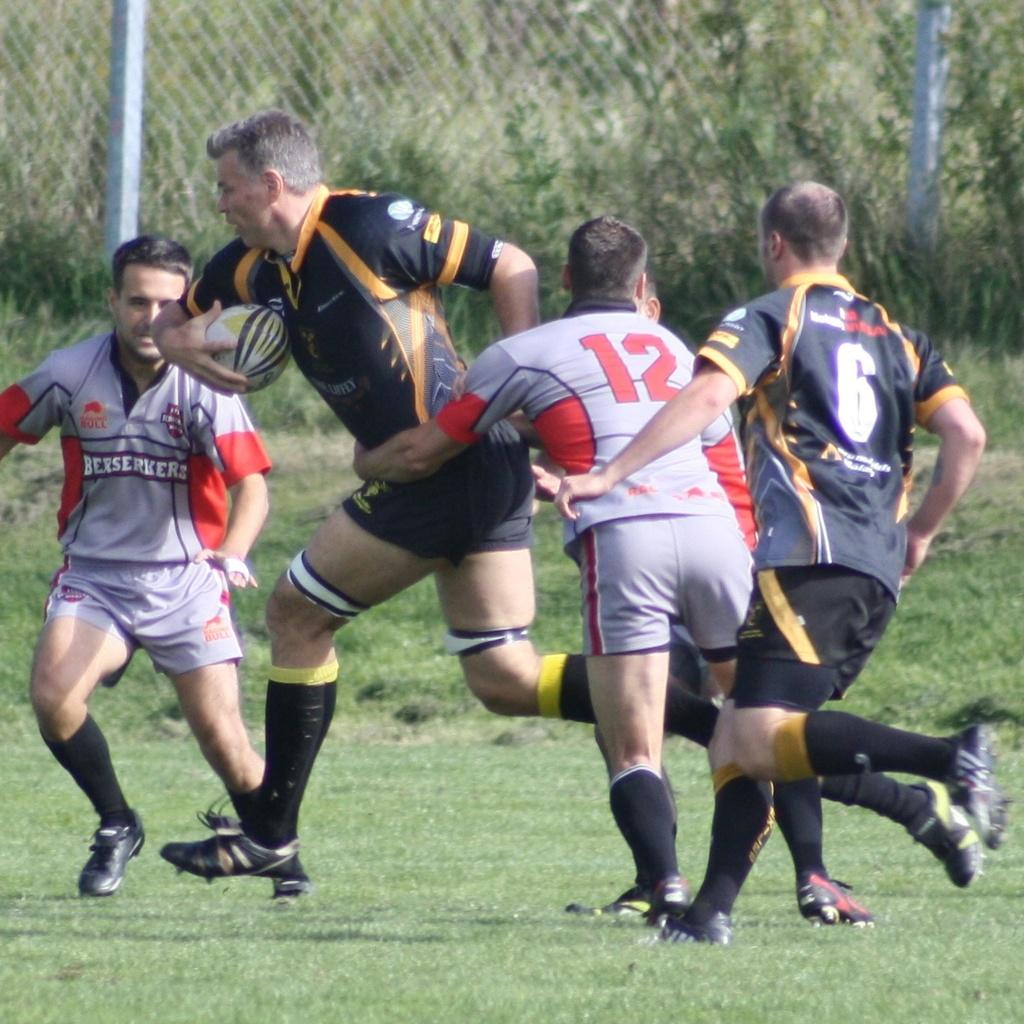What is happening in the image involving a group of people? The group of people are playing a game. Can you describe the setting of the image? There is a railing and a tree in the background of the image. What might be used to separate the playing area from the background? The railing in the background could be used to separate the playing area. How many passengers are sitting in the cart in the image? There is no cart or passengers present in the image. What type of servant can be seen assisting the group of people in the image? There is no servant present in the image; it only shows a group of people playing a game. 